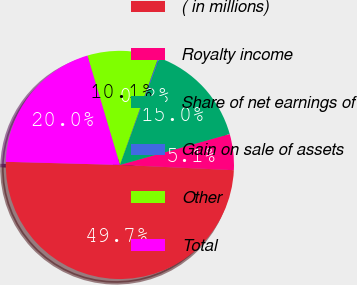Convert chart. <chart><loc_0><loc_0><loc_500><loc_500><pie_chart><fcel>( in millions)<fcel>Royalty income<fcel>Share of net earnings of<fcel>Gain on sale of assets<fcel>Other<fcel>Total<nl><fcel>49.7%<fcel>5.1%<fcel>15.01%<fcel>0.15%<fcel>10.06%<fcel>19.97%<nl></chart> 